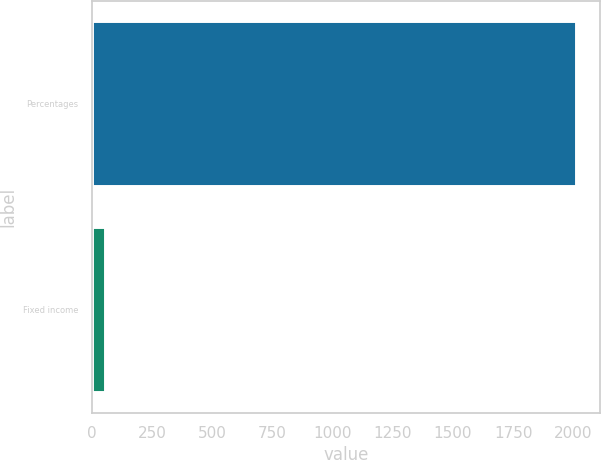Convert chart to OTSL. <chart><loc_0><loc_0><loc_500><loc_500><bar_chart><fcel>Percentages<fcel>Fixed income<nl><fcel>2012<fcel>56<nl></chart> 